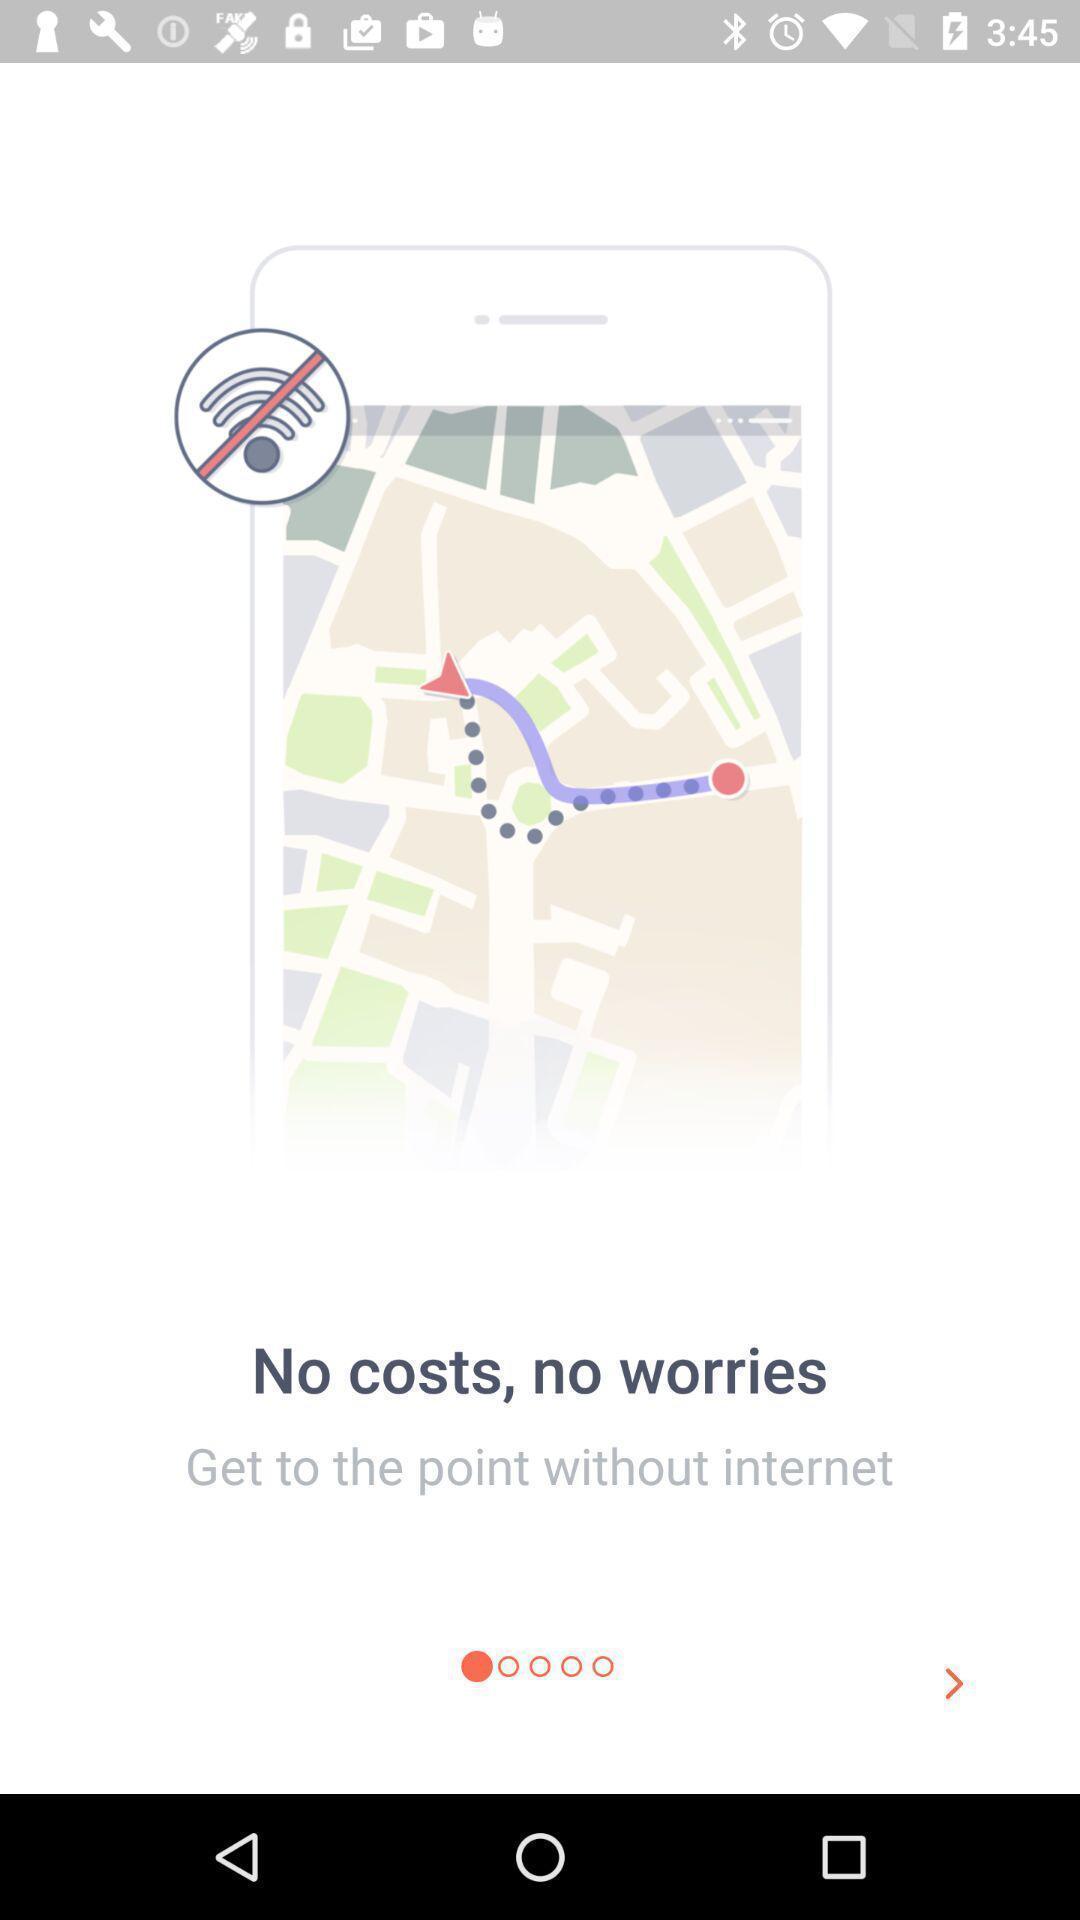Please provide a description for this image. Welcome page of a location app. 